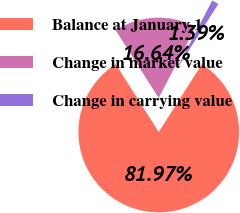Convert chart to OTSL. <chart><loc_0><loc_0><loc_500><loc_500><pie_chart><fcel>Balance at January 1<fcel>Change in market value<fcel>Change in carrying value<nl><fcel>81.97%<fcel>16.64%<fcel>1.39%<nl></chart> 